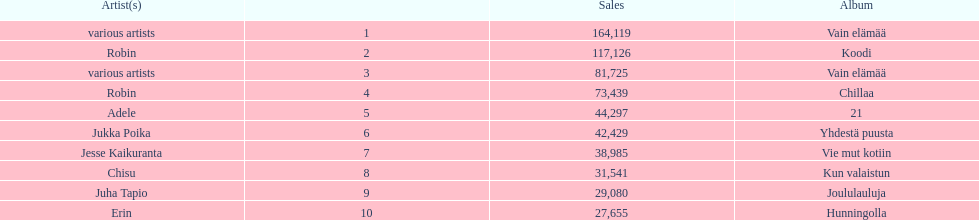Which was better selling, hunningolla or vain elamaa? Vain elämää. 